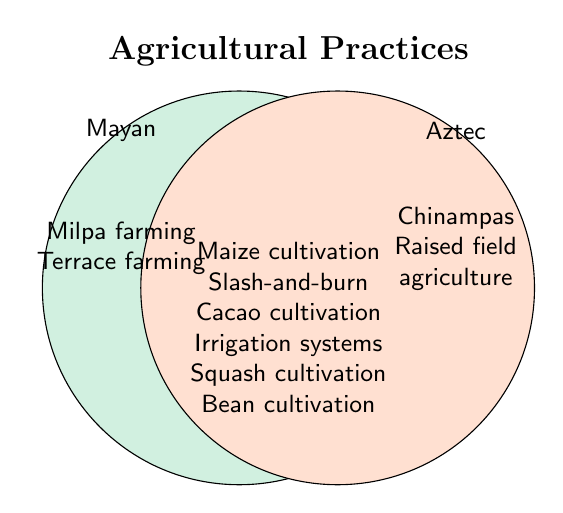What unique agricultural methods are used by the Maya? Look at the section labeled "Mayan" and list the practices only found in that circle.
Answer: Milpa farming, Terrace farming What unique agricultural methods are used by the Aztecs? Look at the section labeled "Aztec" and list the practices only found in that circle.
Answer: Chinampas, Raised field agriculture Which agricultural practices are shared by both Mayan and Aztec civilizations? Check the overlapping section of the two circles to identify the shared practices.
Answer: Maize cultivation, Slash-and-burn, Cacao cultivation, Irrigation systems, Squash cultivation, Bean cultivation How many agricultural practices are mentioned for the Mayan civilization only? Count the entries in the left/non-overlapping part of the Venn diagram.
Answer: 2 Do the Mayans and Aztecs both practice maize cultivation? Determine if maize cultivation is listed in the overlapping section of both circles.
Answer: Yes Which number of agricultural practices is greater, unique to the Aztecs or shared by both civilizations? Count the practices unique to Aztecs and those shared by both, then compare the numbers.
Answer: Shared by both Is terrace farming a shared practice between the Mayans and Aztecs? Check if terrace farming is listed in the overlapping section of the Venn diagram.
Answer: No How many agricultural practices are only unique to either the Mayans or the Aztecs, excluding shared ones? Add the unique practices of the Mayans and Aztecs.
Answer: 4 